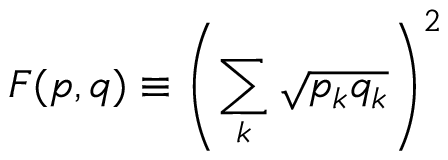<formula> <loc_0><loc_0><loc_500><loc_500>F ( { p } , { q } ) \equiv \left ( \sum _ { k } { \sqrt { p _ { k } q _ { k } } } \right ) ^ { 2 }</formula> 